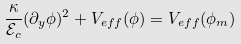<formula> <loc_0><loc_0><loc_500><loc_500>\frac { \kappa } { \mathcal { E } _ { c } } ( \partial _ { y } \phi ) ^ { 2 } + V _ { e f f } ( \phi ) = V _ { e f f } ( \phi _ { m } )</formula> 